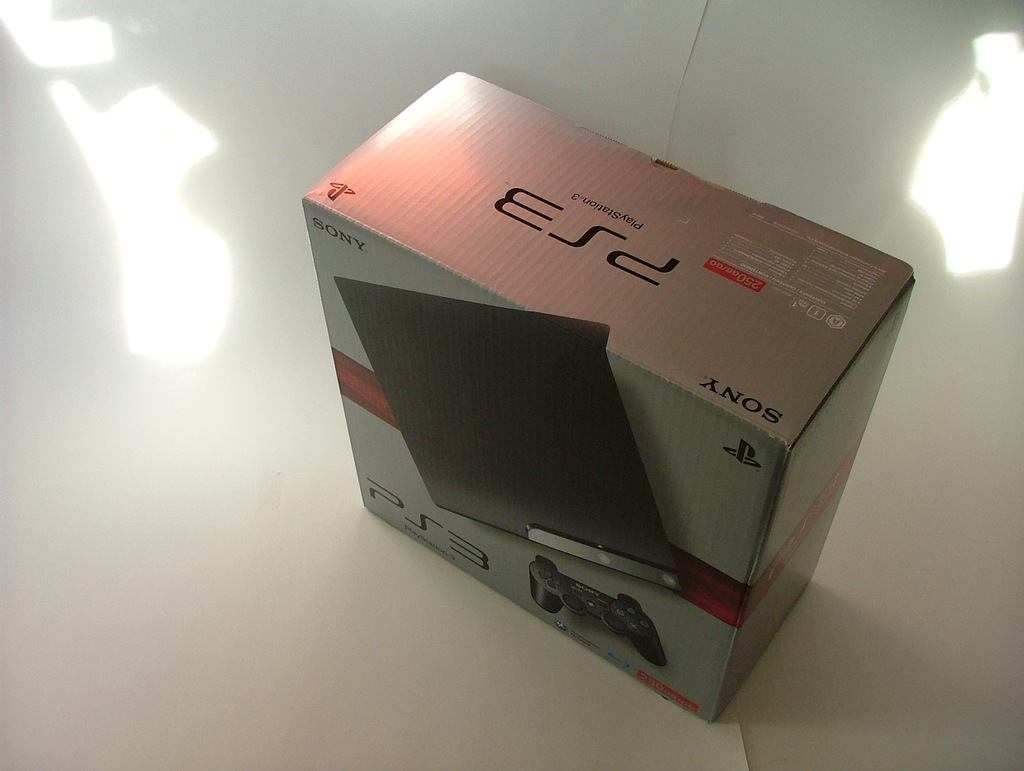How does the lighting affect the appearance of the PS3 box in the image? The lighting in the image casts bright, diffuse reflections and soft shadows around the PS3 box, giving the scene a sleek and modern look. The reflective white surface amplifies these effects, enhancing the overall high-tech aesthetic of the product presentation. 